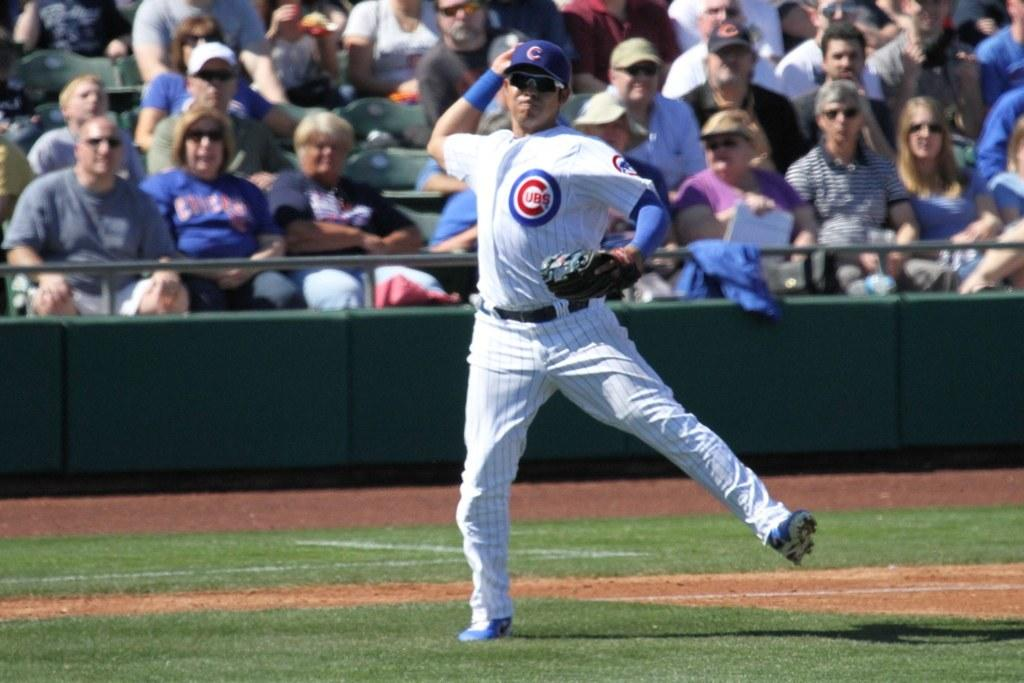<image>
Create a compact narrative representing the image presented. A baseball player is wearing a Cubs uniform and throwing the ball. 